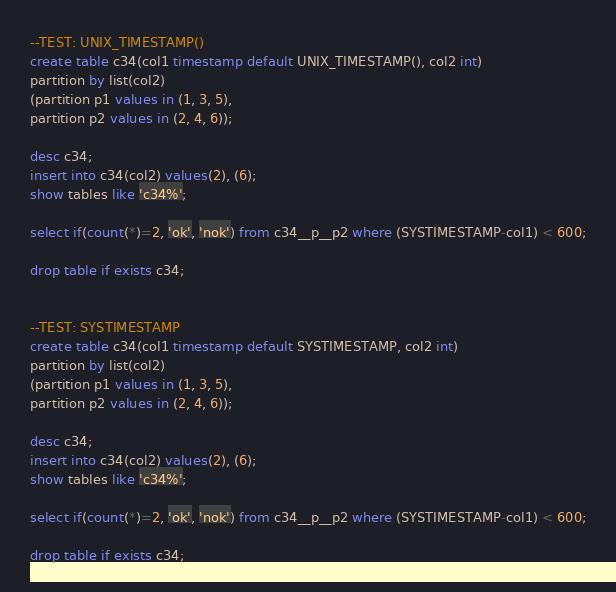Convert code to text. <code><loc_0><loc_0><loc_500><loc_500><_SQL_>

--TEST: UNIX_TIMESTAMP()
create table c34(col1 timestamp default UNIX_TIMESTAMP(), col2 int)
partition by list(col2)
(partition p1 values in (1, 3, 5),
partition p2 values in (2, 4, 6));

desc c34;
insert into c34(col2) values(2), (6);
show tables like 'c34%';

select if(count(*)=2, 'ok', 'nok') from c34__p__p2 where (SYSTIMESTAMP-col1) < 600;

drop table if exists c34;


--TEST: SYSTIMESTAMP
create table c34(col1 timestamp default SYSTIMESTAMP, col2 int)
partition by list(col2)
(partition p1 values in (1, 3, 5),
partition p2 values in (2, 4, 6));

desc c34;
insert into c34(col2) values(2), (6);
show tables like 'c34%';

select if(count(*)=2, 'ok', 'nok') from c34__p__p2 where (SYSTIMESTAMP-col1) < 600;

drop table if exists c34;
</code> 